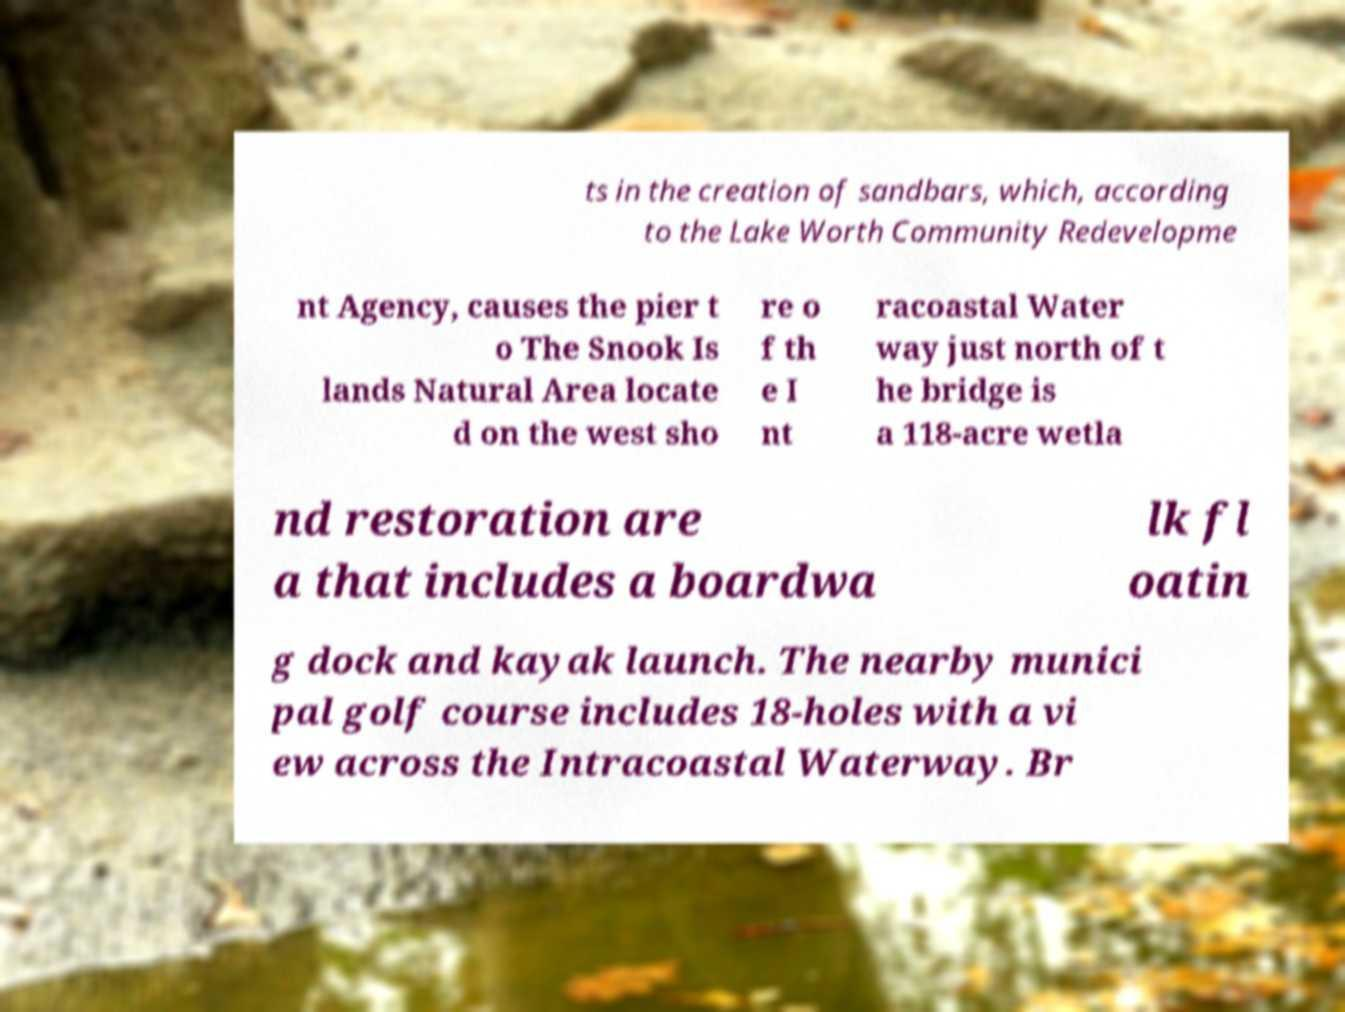Can you accurately transcribe the text from the provided image for me? ts in the creation of sandbars, which, according to the Lake Worth Community Redevelopme nt Agency, causes the pier t o The Snook Is lands Natural Area locate d on the west sho re o f th e I nt racoastal Water way just north of t he bridge is a 118-acre wetla nd restoration are a that includes a boardwa lk fl oatin g dock and kayak launch. The nearby munici pal golf course includes 18-holes with a vi ew across the Intracoastal Waterway. Br 